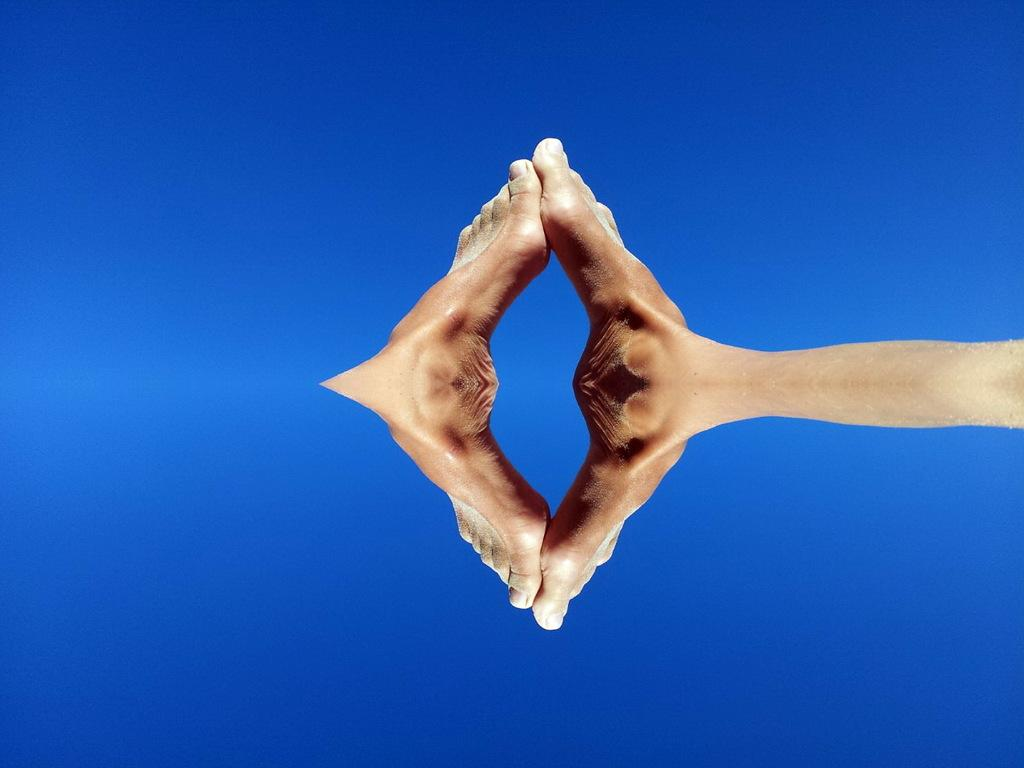What is the main subject of the image? The main subject of the image is an edited picture of a person's leg. What type of produce can be seen growing in the image? There is no produce present in the image; it contains an edited picture of a person's leg. 